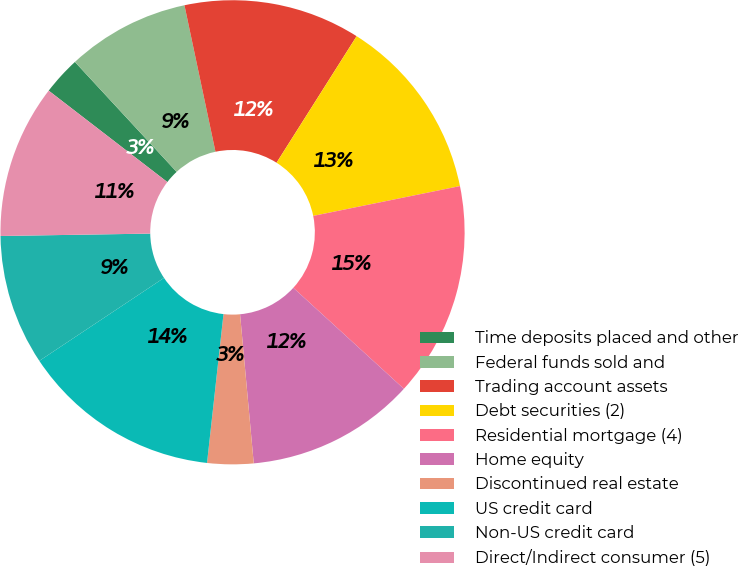Convert chart to OTSL. <chart><loc_0><loc_0><loc_500><loc_500><pie_chart><fcel>Time deposits placed and other<fcel>Federal funds sold and<fcel>Trading account assets<fcel>Debt securities (2)<fcel>Residential mortgage (4)<fcel>Home equity<fcel>Discontinued real estate<fcel>US credit card<fcel>Non-US credit card<fcel>Direct/Indirect consumer (5)<nl><fcel>2.67%<fcel>8.56%<fcel>12.3%<fcel>12.83%<fcel>14.97%<fcel>11.76%<fcel>3.21%<fcel>13.9%<fcel>9.09%<fcel>10.7%<nl></chart> 